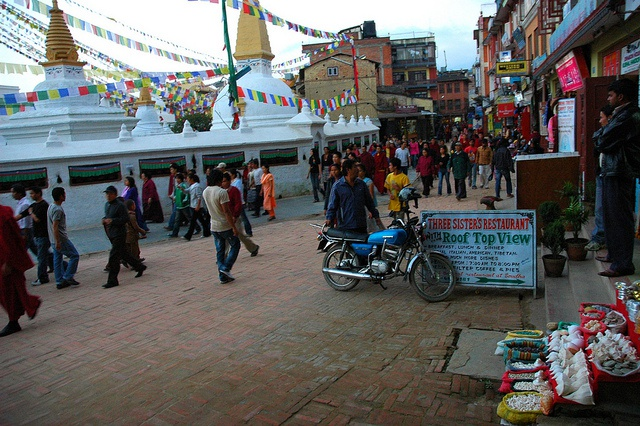Describe the objects in this image and their specific colors. I can see people in lavender, black, gray, and maroon tones, motorcycle in lavender, black, gray, blue, and navy tones, people in lavender, black, navy, maroon, and gray tones, people in lavender, black, and gray tones, and people in lavender, black, gray, darkgray, and maroon tones in this image. 